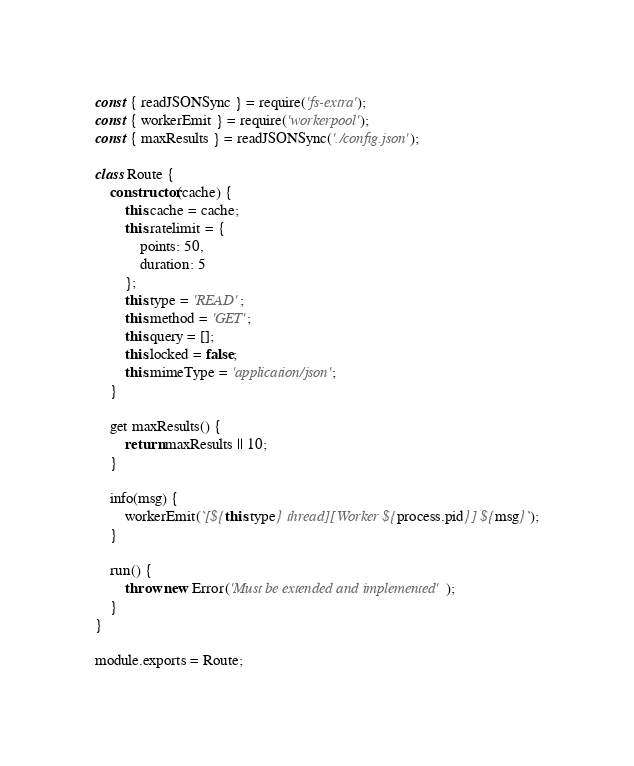Convert code to text. <code><loc_0><loc_0><loc_500><loc_500><_JavaScript_>const { readJSONSync } = require('fs-extra');
const { workerEmit } = require('workerpool');
const { maxResults } = readJSONSync('./config.json');

class Route {
    constructor(cache) {
        this.cache = cache;
        this.ratelimit = {
            points: 50,
            duration: 5
        };
        this.type = 'READ';
        this.method = 'GET';
        this.query = [];
        this.locked = false;
        this.mimeType = 'application/json';
    }

    get maxResults() {
        return maxResults || 10;
    }

    info(msg) {
        workerEmit(`[${this.type} thread][Worker ${process.pid}] ${msg}`);
    }

    run() {
        throw new Error('Must be extended and implemented');
    }
}

module.exports = Route;
</code> 